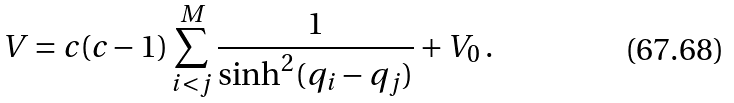<formula> <loc_0><loc_0><loc_500><loc_500>V = c ( c - 1 ) \sum _ { i < j } ^ { M } \frac { 1 } { \sinh ^ { 2 } ( q _ { i } - q _ { j } ) } + V _ { 0 } \, .</formula> 